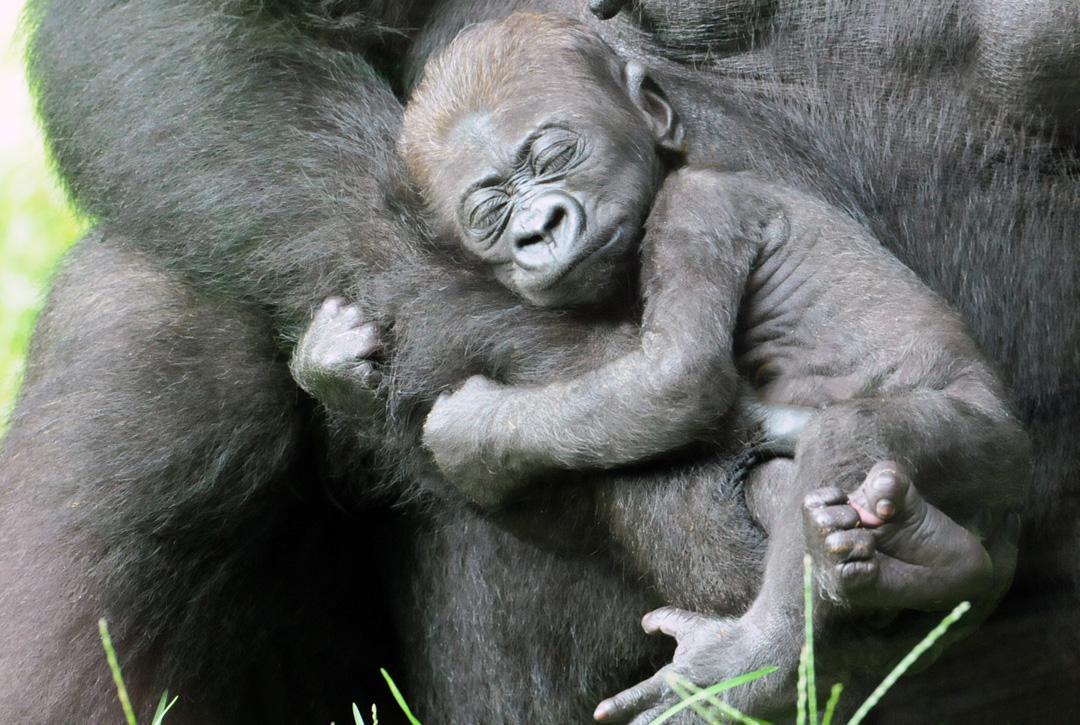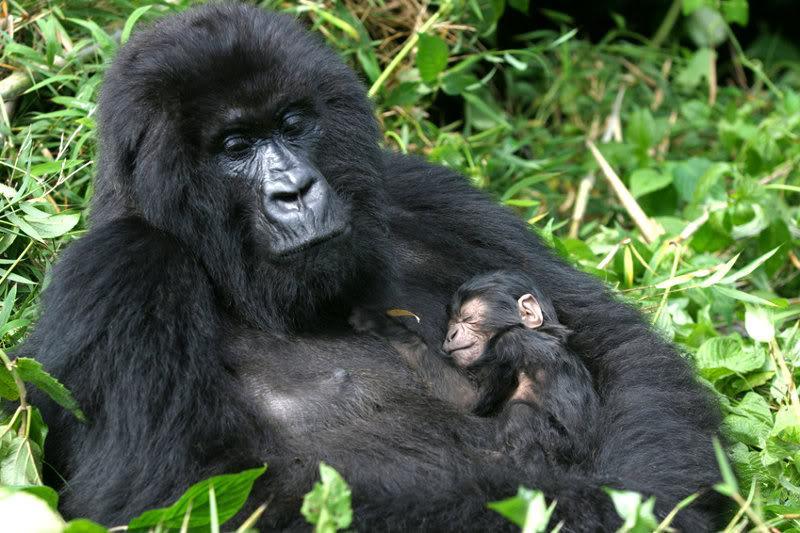The first image is the image on the left, the second image is the image on the right. Analyze the images presented: Is the assertion "There are four gorillas with two pairs touching one another." valid? Answer yes or no. Yes. The first image is the image on the left, the second image is the image on the right. Considering the images on both sides, is "An image shows two gorillas of similar size posed close together, with bodies facing each other." valid? Answer yes or no. No. 